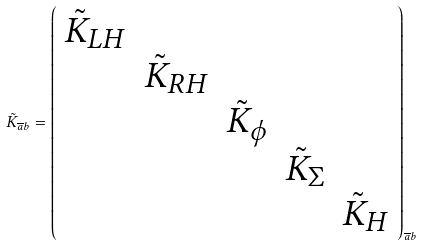Convert formula to latex. <formula><loc_0><loc_0><loc_500><loc_500>\tilde { K } _ { \overline { a } b } = \left ( \begin{array} { c c c c c } \tilde { K } _ { L H } \\ & \tilde { K } _ { R H } \\ & & \tilde { K } _ { \phi } \\ & & & \tilde { K } _ { \Sigma } \\ & & & & \tilde { K } _ { H } \end{array} \right ) _ { \overline { a } b }</formula> 